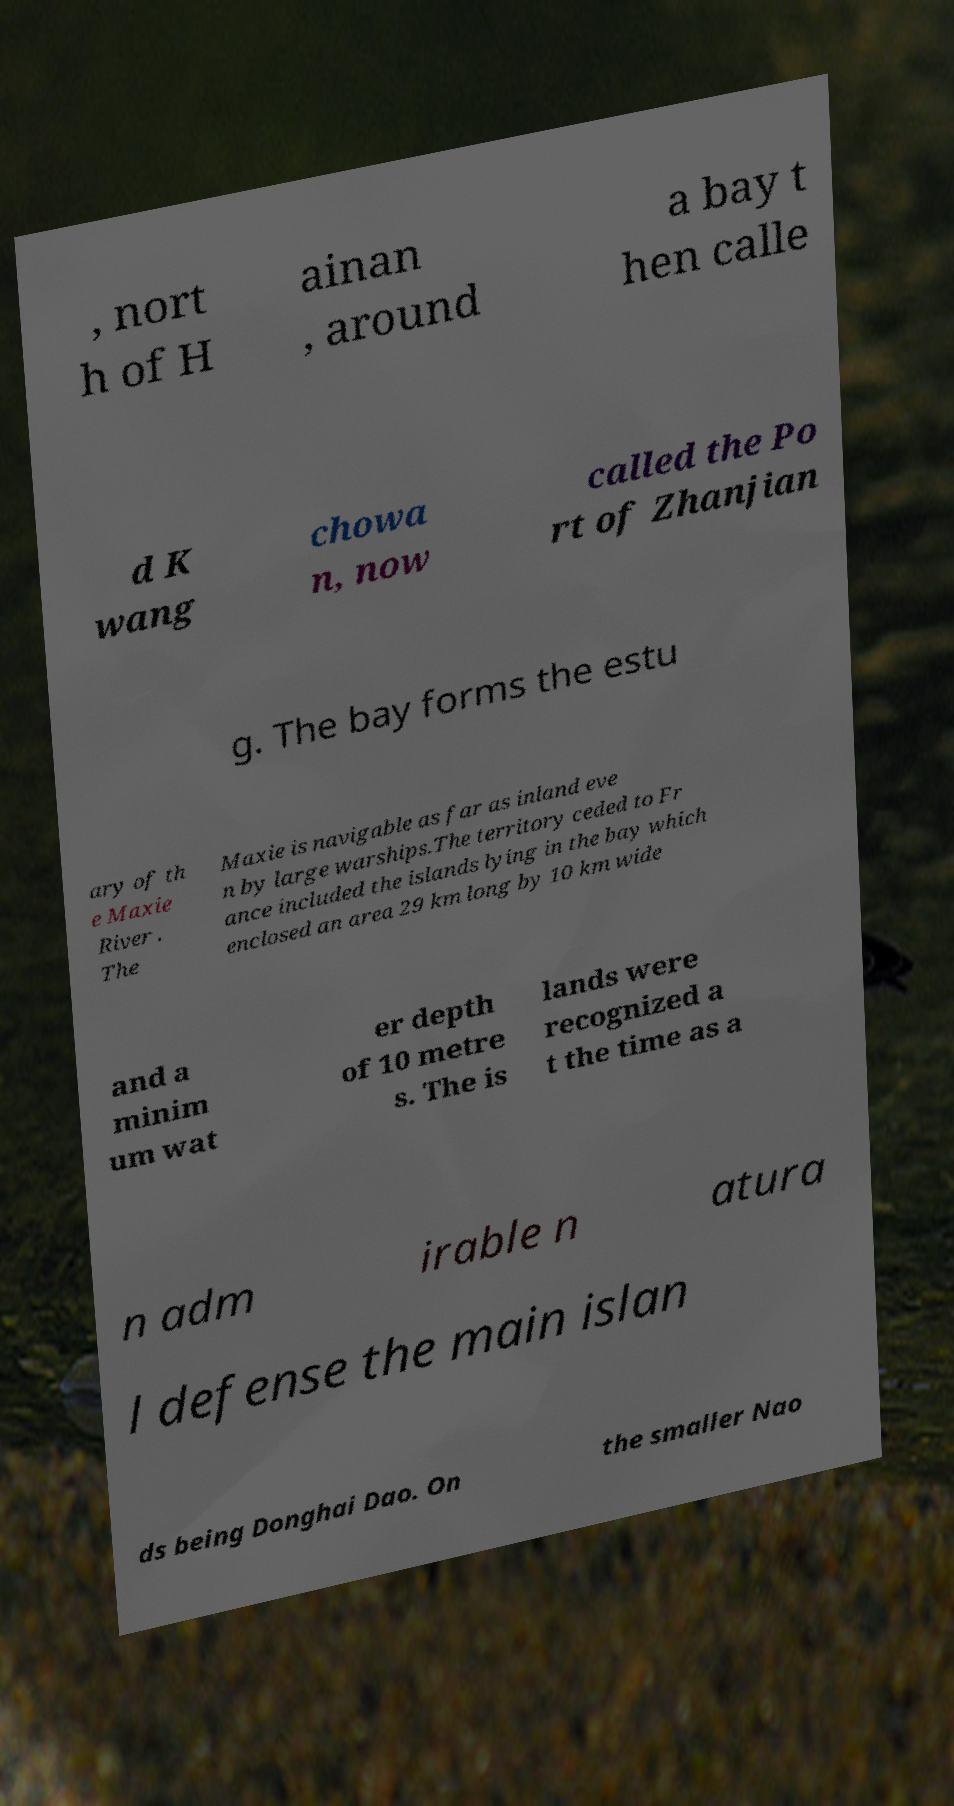For documentation purposes, I need the text within this image transcribed. Could you provide that? , nort h of H ainan , around a bay t hen calle d K wang chowa n, now called the Po rt of Zhanjian g. The bay forms the estu ary of th e Maxie River . The Maxie is navigable as far as inland eve n by large warships.The territory ceded to Fr ance included the islands lying in the bay which enclosed an area 29 km long by 10 km wide and a minim um wat er depth of 10 metre s. The is lands were recognized a t the time as a n adm irable n atura l defense the main islan ds being Donghai Dao. On the smaller Nao 